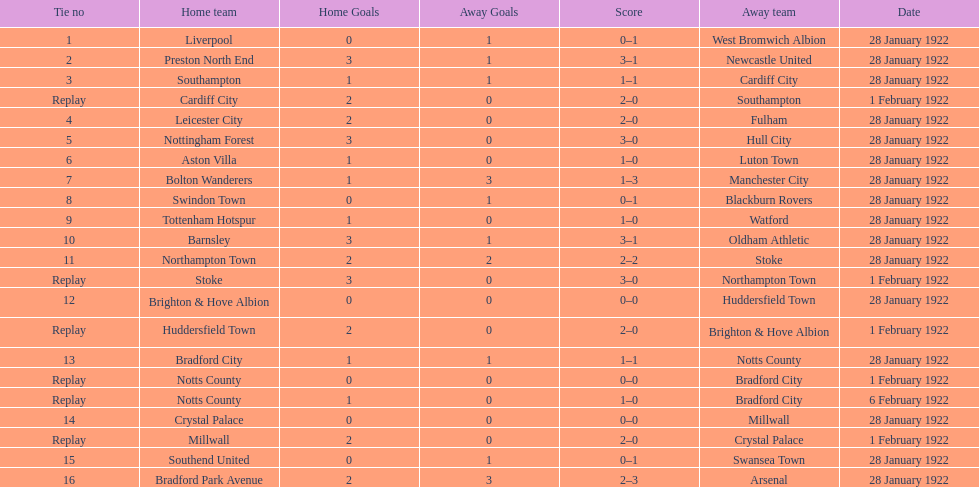How many total points were scored in the second round proper? 45. 